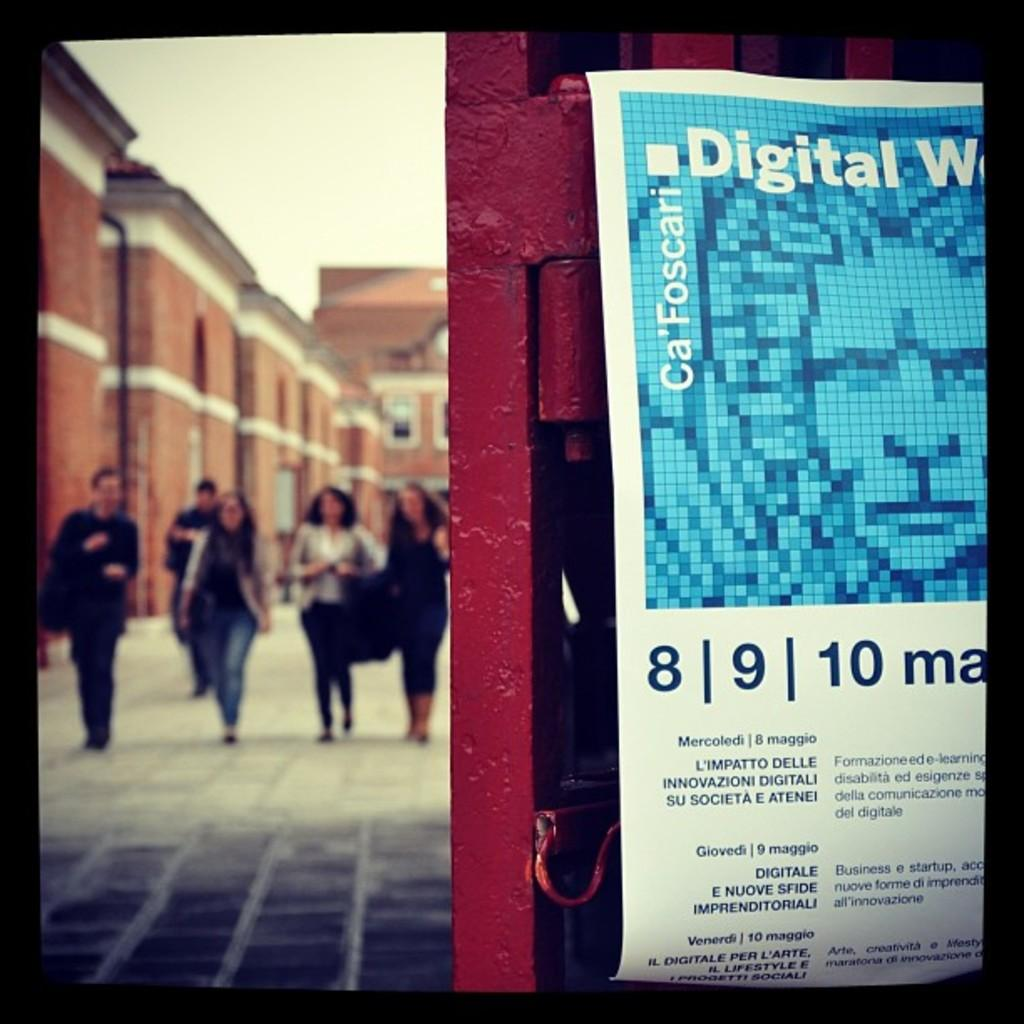What is on the gate in the image? There is a paper poster on the gate. What can be seen behind the people in the image? There are people standing at the back, and a building is visible in the background. How is the image quality at the back of the image? The image is blurry at the back. How many geese are standing next to the building in the image? There are no geese present in the image; it only features a paper poster on the gate, people standing at the back, and a blurry background with a visible building. 